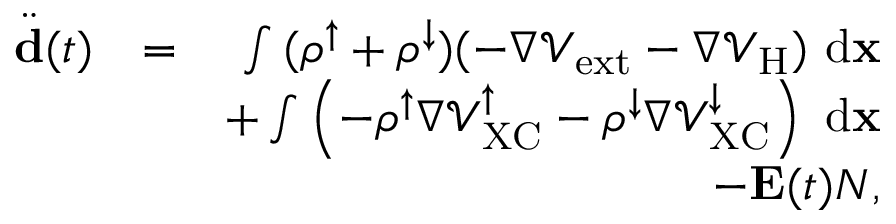Convert formula to latex. <formula><loc_0><loc_0><loc_500><loc_500>\begin{array} { r l r } { \ddot { d } ( t ) } & { = } & { \int { ( \rho ^ { \uparrow } + \rho ^ { \downarrow } ) ( - \nabla \mathcal { V } _ { e x t } - \nabla \mathcal { V } _ { H } ) \ d { x } } } \\ & { + \int { \left ( - \rho ^ { \uparrow } \nabla \mathcal { V } _ { X C } ^ { \uparrow } - \rho ^ { \downarrow } \nabla \mathcal { V } _ { X C } ^ { \downarrow } \right ) \ d { x } } } \\ & { - { E } ( t ) N , } \end{array}</formula> 